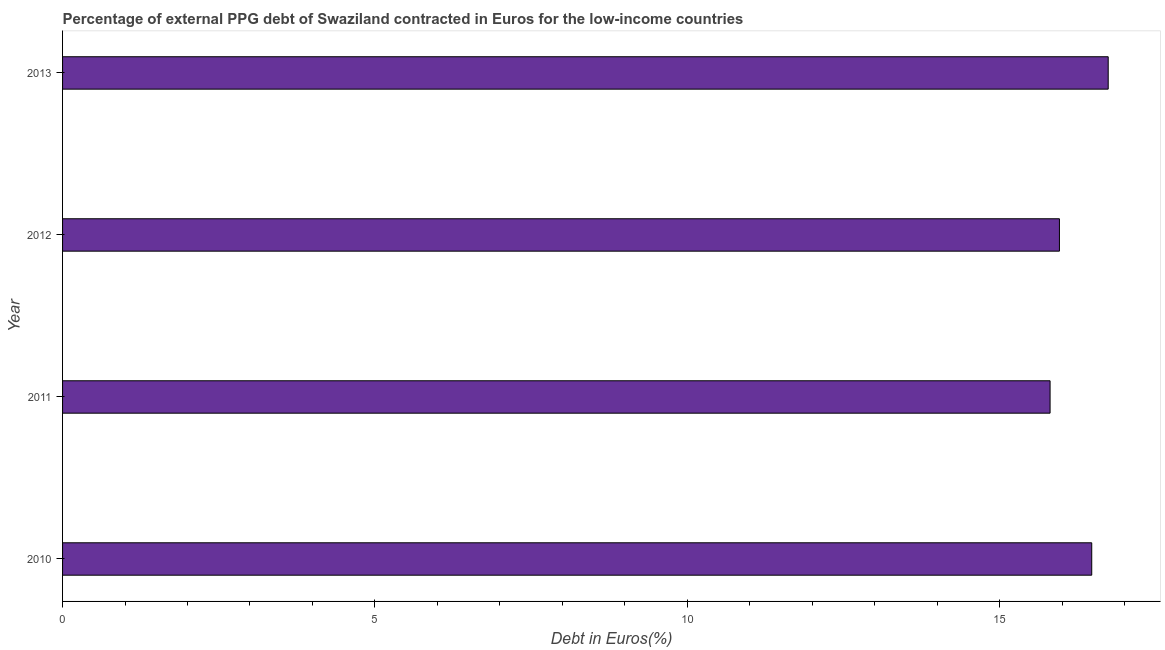Does the graph contain any zero values?
Your answer should be very brief. No. What is the title of the graph?
Ensure brevity in your answer.  Percentage of external PPG debt of Swaziland contracted in Euros for the low-income countries. What is the label or title of the X-axis?
Offer a very short reply. Debt in Euros(%). What is the label or title of the Y-axis?
Ensure brevity in your answer.  Year. What is the currency composition of ppg debt in 2012?
Offer a very short reply. 15.96. Across all years, what is the maximum currency composition of ppg debt?
Your answer should be compact. 16.74. Across all years, what is the minimum currency composition of ppg debt?
Your answer should be very brief. 15.81. In which year was the currency composition of ppg debt minimum?
Provide a succinct answer. 2011. What is the sum of the currency composition of ppg debt?
Your answer should be compact. 64.97. What is the difference between the currency composition of ppg debt in 2010 and 2012?
Ensure brevity in your answer.  0.52. What is the average currency composition of ppg debt per year?
Your response must be concise. 16.24. What is the median currency composition of ppg debt?
Your answer should be very brief. 16.22. What is the ratio of the currency composition of ppg debt in 2010 to that in 2011?
Offer a terse response. 1.04. Is the currency composition of ppg debt in 2010 less than that in 2013?
Your response must be concise. Yes. What is the difference between the highest and the second highest currency composition of ppg debt?
Your response must be concise. 0.26. Is the sum of the currency composition of ppg debt in 2012 and 2013 greater than the maximum currency composition of ppg debt across all years?
Ensure brevity in your answer.  Yes. In how many years, is the currency composition of ppg debt greater than the average currency composition of ppg debt taken over all years?
Your response must be concise. 2. How many bars are there?
Your answer should be very brief. 4. Are all the bars in the graph horizontal?
Make the answer very short. Yes. What is the Debt in Euros(%) of 2010?
Your response must be concise. 16.47. What is the Debt in Euros(%) of 2011?
Offer a terse response. 15.81. What is the Debt in Euros(%) in 2012?
Ensure brevity in your answer.  15.96. What is the Debt in Euros(%) of 2013?
Provide a short and direct response. 16.74. What is the difference between the Debt in Euros(%) in 2010 and 2011?
Give a very brief answer. 0.67. What is the difference between the Debt in Euros(%) in 2010 and 2012?
Offer a very short reply. 0.52. What is the difference between the Debt in Euros(%) in 2010 and 2013?
Ensure brevity in your answer.  -0.26. What is the difference between the Debt in Euros(%) in 2011 and 2012?
Your answer should be very brief. -0.15. What is the difference between the Debt in Euros(%) in 2011 and 2013?
Your answer should be compact. -0.93. What is the difference between the Debt in Euros(%) in 2012 and 2013?
Keep it short and to the point. -0.78. What is the ratio of the Debt in Euros(%) in 2010 to that in 2011?
Offer a terse response. 1.04. What is the ratio of the Debt in Euros(%) in 2010 to that in 2012?
Offer a very short reply. 1.03. What is the ratio of the Debt in Euros(%) in 2010 to that in 2013?
Keep it short and to the point. 0.98. What is the ratio of the Debt in Euros(%) in 2011 to that in 2012?
Offer a terse response. 0.99. What is the ratio of the Debt in Euros(%) in 2011 to that in 2013?
Offer a very short reply. 0.94. What is the ratio of the Debt in Euros(%) in 2012 to that in 2013?
Provide a succinct answer. 0.95. 